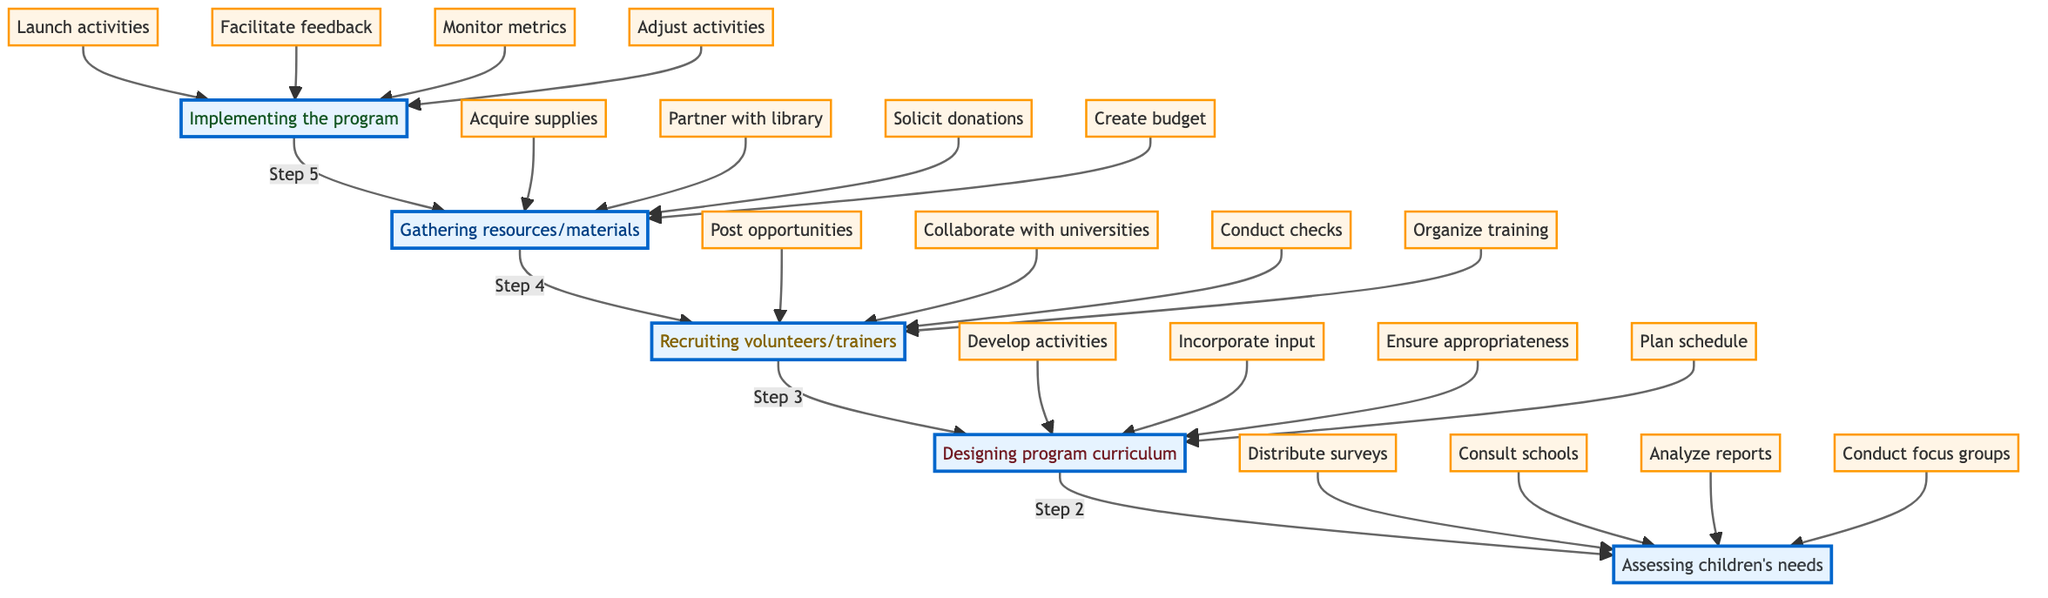What is the last step in the flow chart? The last step in the flow chart, which is positioned at the bottom, is "Implementing the program." This step is the final action taken after all the other steps have been completed.
Answer: Implementing the program How many total steps are there in the diagram? The diagram includes five distinct steps, which correspond to different phases in coordinating after-school programs for children.
Answer: Five Which step comes directly before "Recruiting volunteers/trainers"? "Gathering resources/materials" comes directly before the "Recruiting volunteers/trainers" step, indicating it is a prerequisite action prior to recruiting.
Answer: Gathering resources/materials What action is taken under "Assessing children's needs"? One of the actions taken under "Assessing children's needs" is to "Distribute surveys to parents and guardians to understand children's interests and needs." This is part of the effort to gather relevant data on children's requirements.
Answer: Distribute surveys What is the purpose of distributing surveys? The purpose of distributing surveys is to understand children's interests and needs, aiding in the overall assessment phase of program planning. This helps tailor the program to meet children's specific requirements.
Answer: Understand children's interests and needs Which step has the action "Acquire educational supplies from local stores and online retailers"? The action "Acquire educational supplies from local stores and online retailers" is listed under the "Gathering resources/materials" step. This step is focused on gathering the necessary materials to support the program.
Answer: Gathering resources/materials How does the "Designing program curriculum" step relate to assessing children's needs? The "Designing program curriculum" step relies on the findings from the "Assessing children's needs" step, as it incorporates input from parents, teachers, and community members based on the needs identified in the assessment phase.
Answer: It relies on findings from assessing children's needs Which action involves collaboration with local universities? The action that involves collaboration with local universities is "Collaborate with local universities and colleges to enlist student volunteers," which is part of the "Recruiting volunteers/trainers" step.
Answer: Collaborate with local universities What step follows after "Gathering resources/materials"? The step that follows after "Gathering resources/materials" is "Recruiting volunteers/trainers." This indicates a logical sequence where resources are gathered before enlisting personnel.
Answer: Recruiting volunteers/trainers 